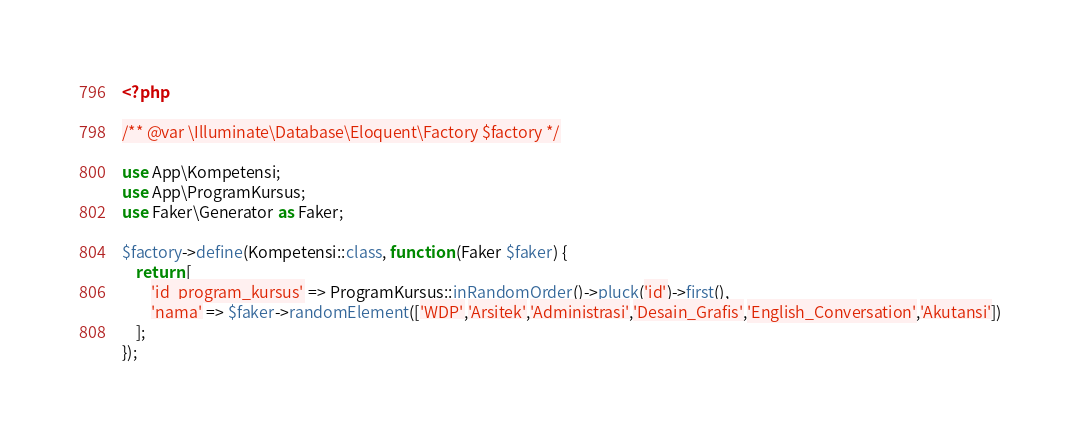Convert code to text. <code><loc_0><loc_0><loc_500><loc_500><_PHP_><?php

/** @var \Illuminate\Database\Eloquent\Factory $factory */

use App\Kompetensi;
use App\ProgramKursus;
use Faker\Generator as Faker;

$factory->define(Kompetensi::class, function (Faker $faker) {
    return [
        'id_program_kursus' => ProgramKursus::inRandomOrder()->pluck('id')->first(),
        'nama' => $faker->randomElement(['WDP','Arsitek','Administrasi','Desain_Grafis','English_Conversation','Akutansi'])  
    ];
});
</code> 